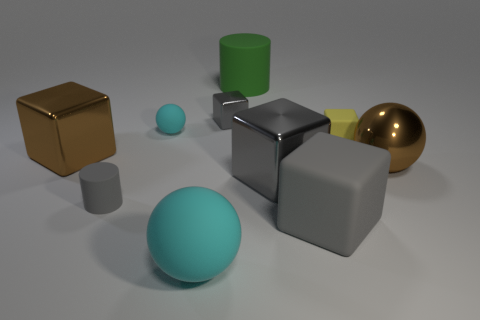Subtract 1 cyan balls. How many objects are left? 9 Subtract all balls. How many objects are left? 7 Subtract 4 cubes. How many cubes are left? 1 Subtract all brown blocks. Subtract all blue cylinders. How many blocks are left? 4 Subtract all red cubes. How many green cylinders are left? 1 Subtract all big objects. Subtract all large brown metal balls. How many objects are left? 3 Add 2 small cyan objects. How many small cyan objects are left? 3 Add 8 large gray rubber cubes. How many large gray rubber cubes exist? 9 Subtract all green cylinders. How many cylinders are left? 1 Subtract all small cyan matte spheres. How many spheres are left? 2 